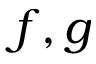Convert formula to latex. <formula><loc_0><loc_0><loc_500><loc_500>f , g</formula> 